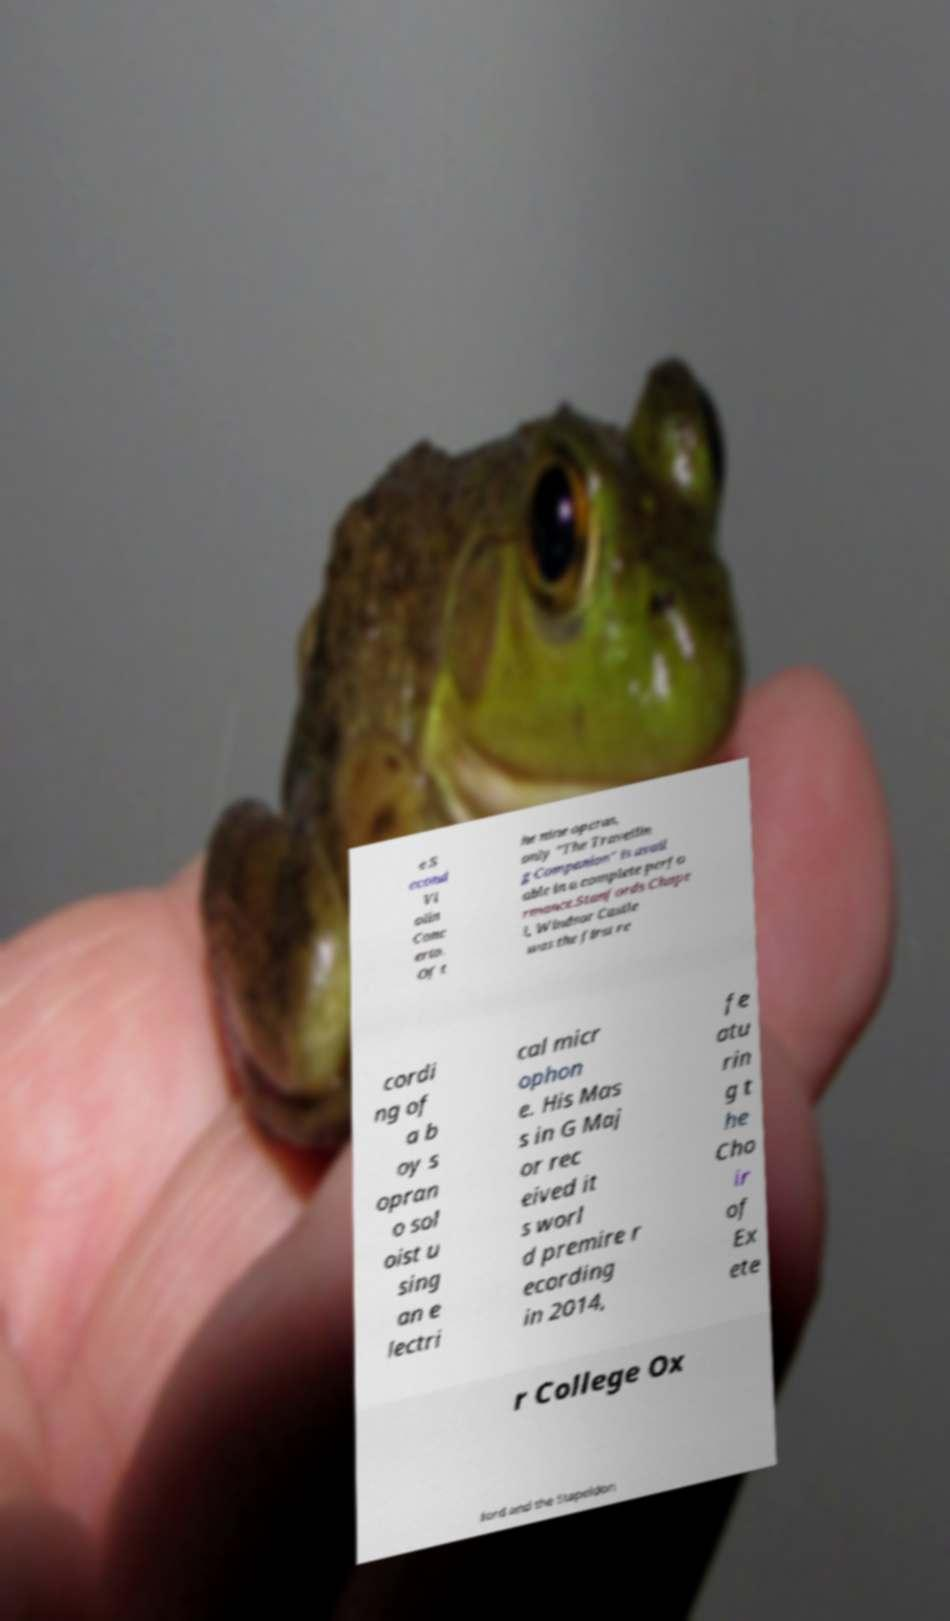Can you read and provide the text displayed in the image?This photo seems to have some interesting text. Can you extract and type it out for me? e S econd Vi olin Conc erto. Of t he nine operas, only "The Travellin g Companion" is avail able in a complete perfo rmance.Stanfords Chape l, Windsor Castle was the first re cordi ng of a b oy s opran o sol oist u sing an e lectri cal micr ophon e. His Mas s in G Maj or rec eived it s worl d premire r ecording in 2014, fe atu rin g t he Cho ir of Ex ete r College Ox ford and the Stapeldon 